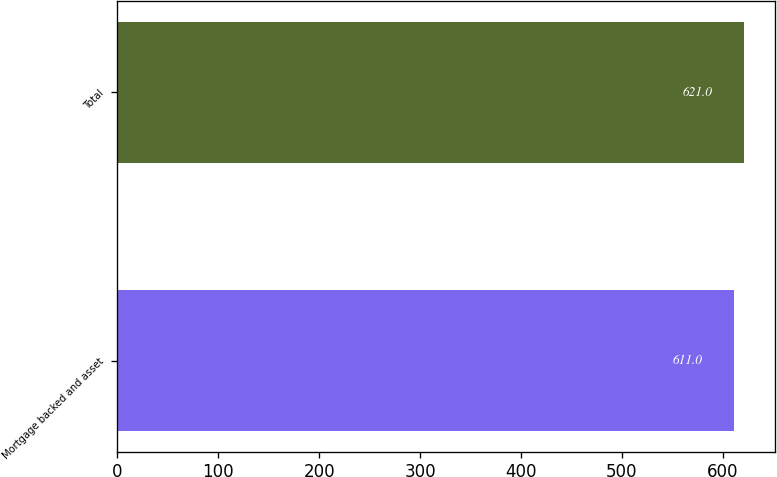Convert chart to OTSL. <chart><loc_0><loc_0><loc_500><loc_500><bar_chart><fcel>Mortgage backed and asset<fcel>Total<nl><fcel>611<fcel>621<nl></chart> 